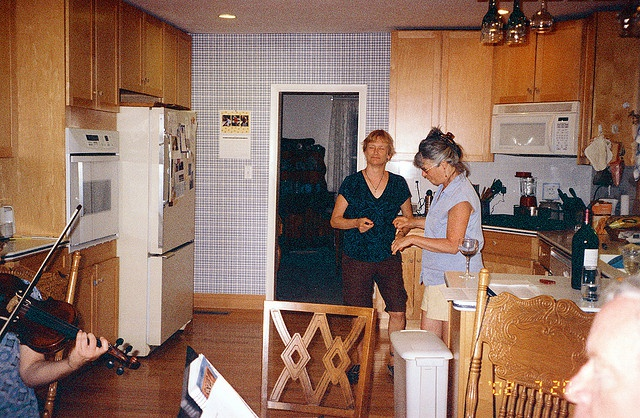Describe the objects in this image and their specific colors. I can see refrigerator in black, lightgray, gray, and tan tones, people in black, brown, and maroon tones, chair in black, brown, tan, and red tones, chair in black, maroon, brown, and white tones, and people in black, darkgray, tan, and brown tones in this image. 